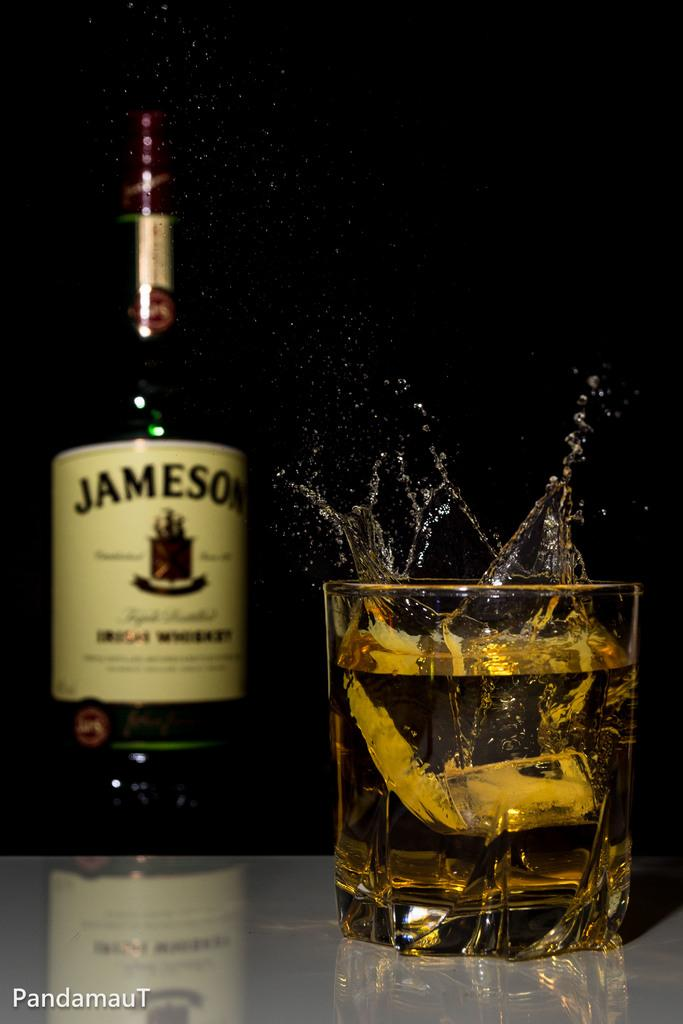Provide a one-sentence caption for the provided image. A bottle on Jameson Irish Whiskey is next to a glass of whiskey. 